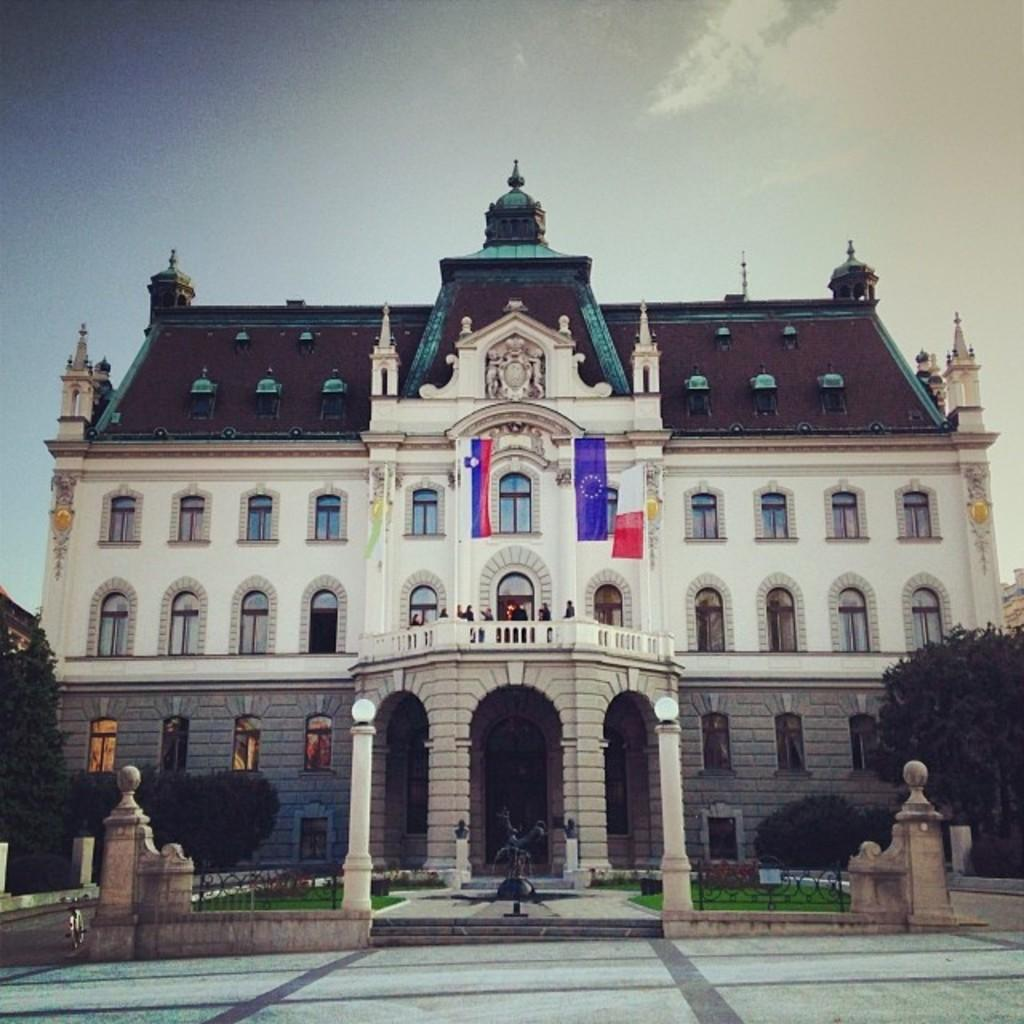What type of surface can be seen in the image? The ground is visible in the image. What type of vegetation is present in the image? There is grass in the image. What type of structure is present in the image? There is a statue in the image. What type of natural elements are present in the image? There are trees in the image. What type of symbolic objects are present in the image? There are flags in the image. What type of architectural structure is present in the image? There is a building with windows in the image. What type of objects are present in the image? There are some objects in the image. What type of atmospheric element is visible in the background of the image? The sky is visible in the background of the image. Where can the worm be seen crawling in the image? There is no worm present in the image. What type of wire is used to hold the scissors in the image? There are no scissors or wire present in the image. 